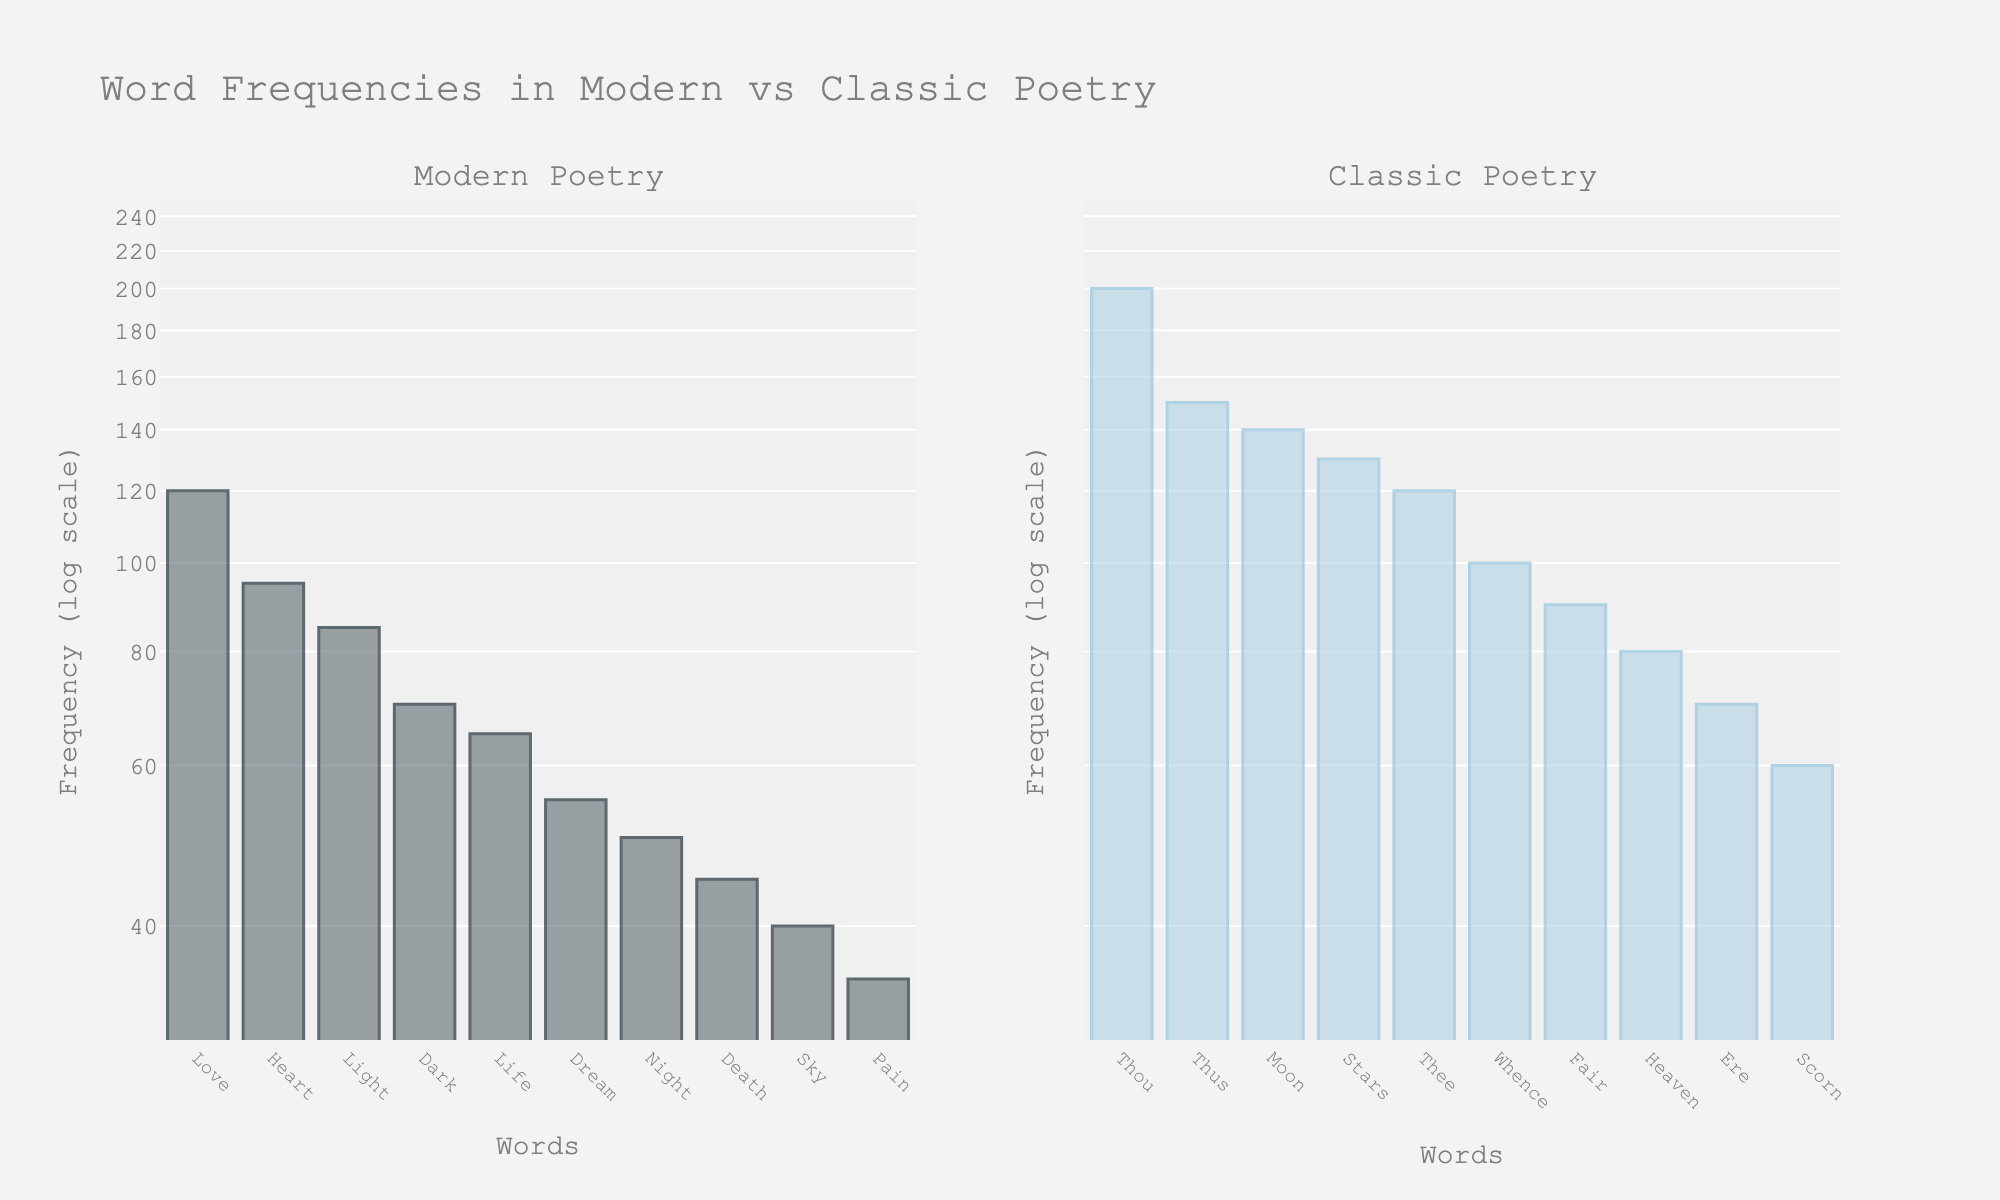what is the title of the figure? The title is displayed at the top center of the figure and reads, "Word Frequencies in Modern vs Classic Poetry".
Answer: Word Frequencies in Modern vs Classic Poetry What is the range of frequencies displayed on the y-axis? The y-axis has a log scale representing word frequencies, ranging from approximately 30 to 250. This is evident from the range [np.log10(30), np.log10(250)] specified.
Answer: ~30 to 250 Which word has the highest frequency in modern poetry and what is its frequency? In the modern poetry subplot, the word "Love" has the highest bar, indicating it has the highest frequency of 120. This is also confirmed by the data where "Love" occurs 120 times.
Answer: Love, 120 What is the color of the bars representing classic poetry? The bars representing classic poetry are colored in a light blue tone with darker blue edges. This can be inferred from the description in the data where classic poetry bars are marked with a specific color set.
Answer: Light blue with darker blue edges Which word in classic poetry has the lowest frequency, and what is that frequency? The word "Scorn" in the classic poetry subplot has the shortest bar, indicating it has the lowest frequency of 60. This is also confirmed in the given data.
Answer: Scorn, 60 How does the frequency of the word "Heart" in modern poetry compare to "Thee" in classic poetry? The word "Heart" in modern poetry has a frequency of 95, while "Thee" in classic poetry has a frequency of 120. "Thee" appears more frequently than "Heart".
Answer: Thee appears more frequently What is the difference between the frequency of "Moon" in classic poetry and "Light" in modern poetry? The frequency of "Moon" in classic poetry is 140, and "Light" in modern poetry is 85. The difference is 140 - 85 = 55.
Answer: 55 If you sum the frequencies of the top three words in modern poetry, what is the total frequency? The top three words in modern poetry are "Love" (120), "Heart" (95), and "Light" (85). Their total frequency is 120 + 95 + 85 = 300.
Answer: 300 How many unique words are displayed in each poetry type? By counting the bars in each subplot, there are 10 unique words displayed for both modern poetry and classic poetry. This matches the data where each type has 10 words listed.
Answer: 10 each 